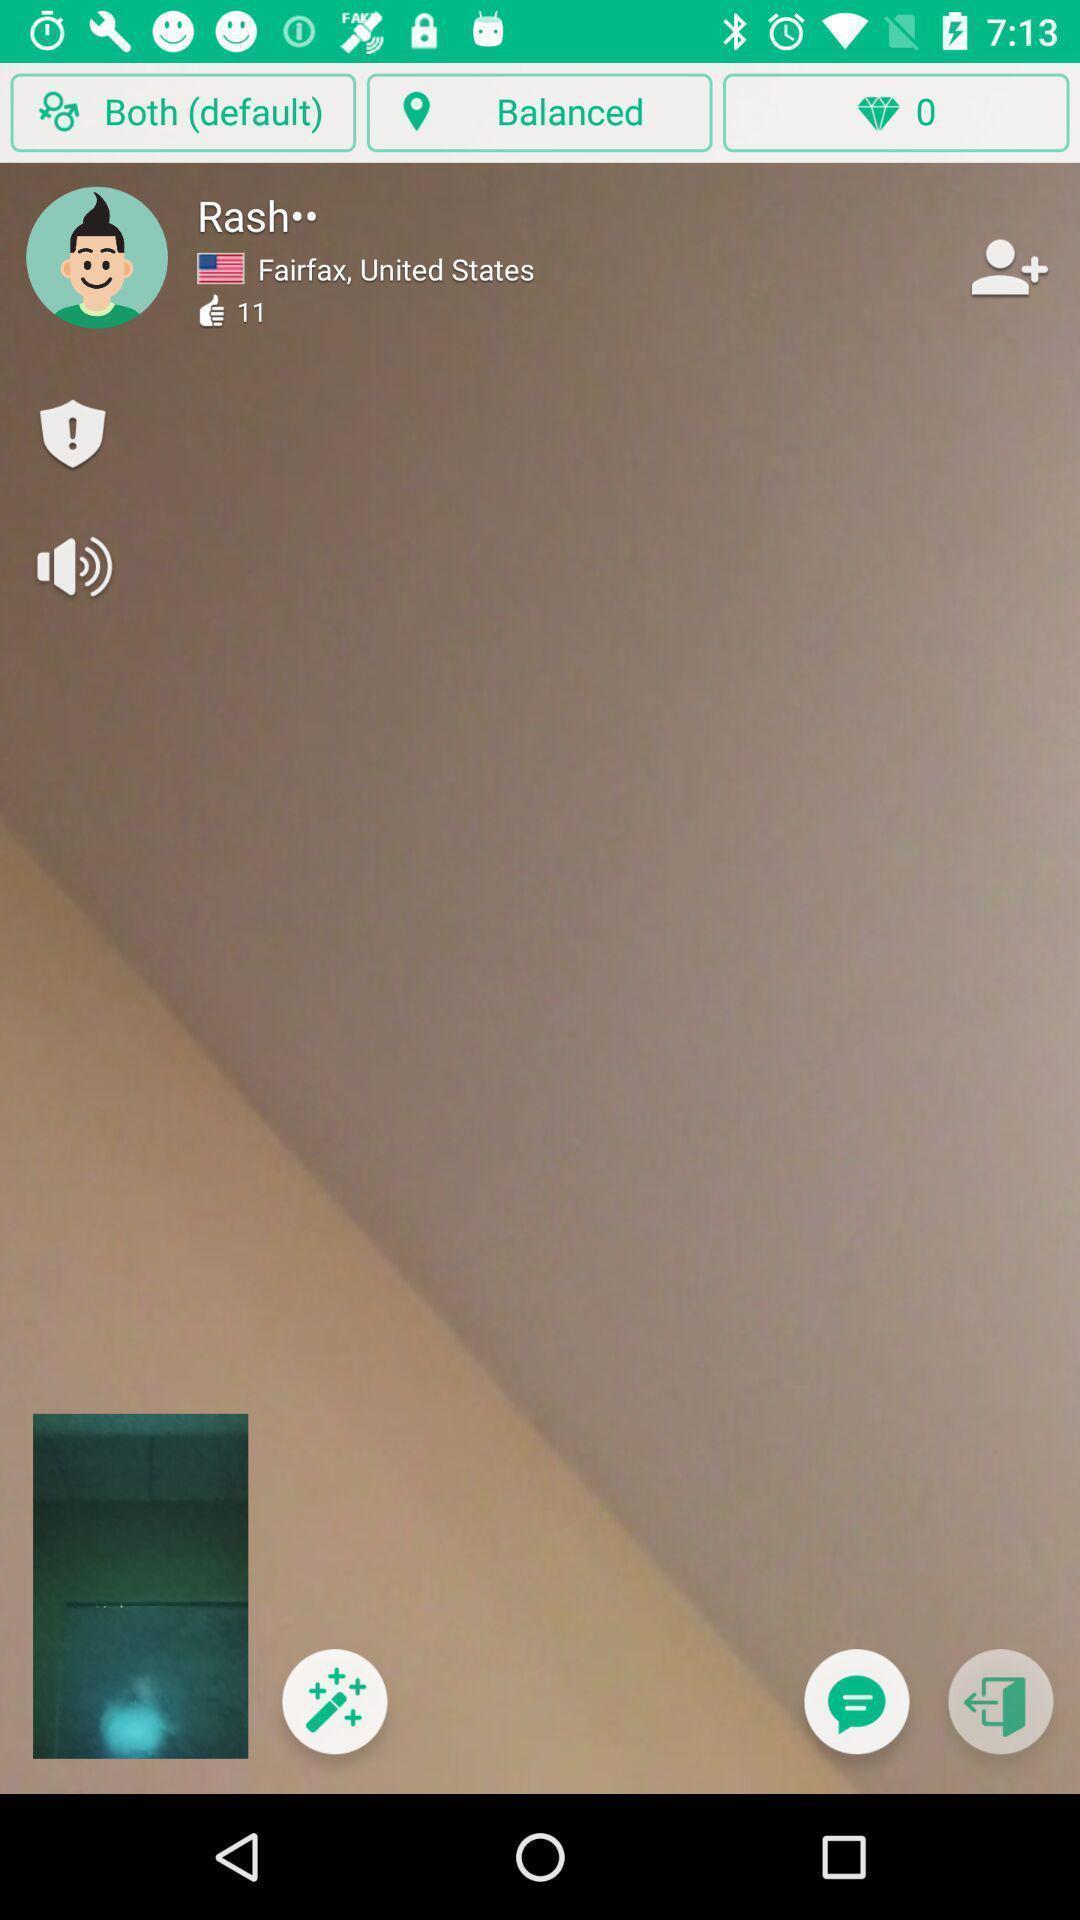Tell me about the visual elements in this screen capture. Screen shows different options in a communication app. 